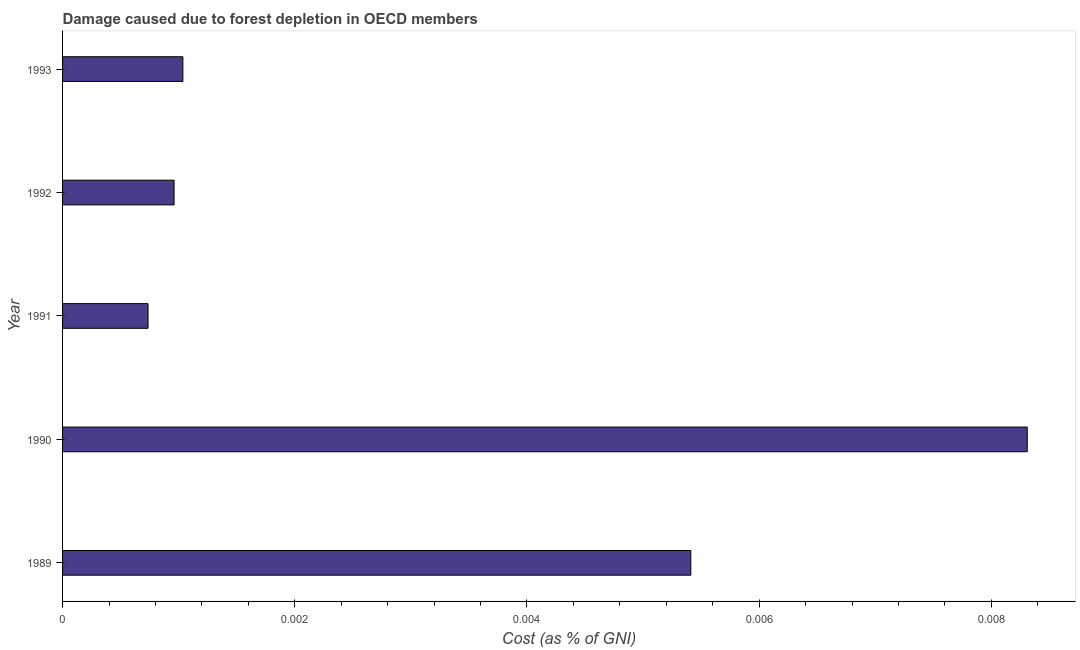Does the graph contain any zero values?
Provide a succinct answer. No. What is the title of the graph?
Your response must be concise. Damage caused due to forest depletion in OECD members. What is the label or title of the X-axis?
Your answer should be very brief. Cost (as % of GNI). What is the damage caused due to forest depletion in 1991?
Give a very brief answer. 0. Across all years, what is the maximum damage caused due to forest depletion?
Your answer should be compact. 0.01. Across all years, what is the minimum damage caused due to forest depletion?
Keep it short and to the point. 0. In which year was the damage caused due to forest depletion minimum?
Provide a succinct answer. 1991. What is the sum of the damage caused due to forest depletion?
Offer a very short reply. 0.02. What is the difference between the damage caused due to forest depletion in 1991 and 1992?
Your answer should be compact. -0. What is the average damage caused due to forest depletion per year?
Give a very brief answer. 0. What is the median damage caused due to forest depletion?
Ensure brevity in your answer.  0. Do a majority of the years between 1991 and 1989 (inclusive) have damage caused due to forest depletion greater than 0.002 %?
Provide a succinct answer. Yes. What is the ratio of the damage caused due to forest depletion in 1990 to that in 1991?
Offer a terse response. 11.29. Is the difference between the damage caused due to forest depletion in 1992 and 1993 greater than the difference between any two years?
Give a very brief answer. No. What is the difference between the highest and the second highest damage caused due to forest depletion?
Offer a very short reply. 0. Is the sum of the damage caused due to forest depletion in 1990 and 1991 greater than the maximum damage caused due to forest depletion across all years?
Your response must be concise. Yes. In how many years, is the damage caused due to forest depletion greater than the average damage caused due to forest depletion taken over all years?
Make the answer very short. 2. How many bars are there?
Provide a short and direct response. 5. What is the difference between two consecutive major ticks on the X-axis?
Offer a very short reply. 0. What is the Cost (as % of GNI) of 1989?
Your response must be concise. 0.01. What is the Cost (as % of GNI) in 1990?
Offer a very short reply. 0.01. What is the Cost (as % of GNI) in 1991?
Provide a short and direct response. 0. What is the Cost (as % of GNI) of 1992?
Keep it short and to the point. 0. What is the Cost (as % of GNI) in 1993?
Keep it short and to the point. 0. What is the difference between the Cost (as % of GNI) in 1989 and 1990?
Ensure brevity in your answer.  -0. What is the difference between the Cost (as % of GNI) in 1989 and 1991?
Your answer should be very brief. 0. What is the difference between the Cost (as % of GNI) in 1989 and 1992?
Your answer should be very brief. 0. What is the difference between the Cost (as % of GNI) in 1989 and 1993?
Ensure brevity in your answer.  0. What is the difference between the Cost (as % of GNI) in 1990 and 1991?
Give a very brief answer. 0.01. What is the difference between the Cost (as % of GNI) in 1990 and 1992?
Offer a terse response. 0.01. What is the difference between the Cost (as % of GNI) in 1990 and 1993?
Your answer should be very brief. 0.01. What is the difference between the Cost (as % of GNI) in 1991 and 1992?
Your answer should be compact. -0. What is the difference between the Cost (as % of GNI) in 1991 and 1993?
Your answer should be compact. -0. What is the difference between the Cost (as % of GNI) in 1992 and 1993?
Offer a very short reply. -8e-5. What is the ratio of the Cost (as % of GNI) in 1989 to that in 1990?
Keep it short and to the point. 0.65. What is the ratio of the Cost (as % of GNI) in 1989 to that in 1991?
Your answer should be very brief. 7.35. What is the ratio of the Cost (as % of GNI) in 1989 to that in 1992?
Provide a short and direct response. 5.63. What is the ratio of the Cost (as % of GNI) in 1989 to that in 1993?
Provide a short and direct response. 5.22. What is the ratio of the Cost (as % of GNI) in 1990 to that in 1991?
Provide a short and direct response. 11.29. What is the ratio of the Cost (as % of GNI) in 1990 to that in 1992?
Your answer should be compact. 8.65. What is the ratio of the Cost (as % of GNI) in 1990 to that in 1993?
Your answer should be compact. 8.02. What is the ratio of the Cost (as % of GNI) in 1991 to that in 1992?
Give a very brief answer. 0.77. What is the ratio of the Cost (as % of GNI) in 1991 to that in 1993?
Offer a terse response. 0.71. What is the ratio of the Cost (as % of GNI) in 1992 to that in 1993?
Your answer should be very brief. 0.93. 